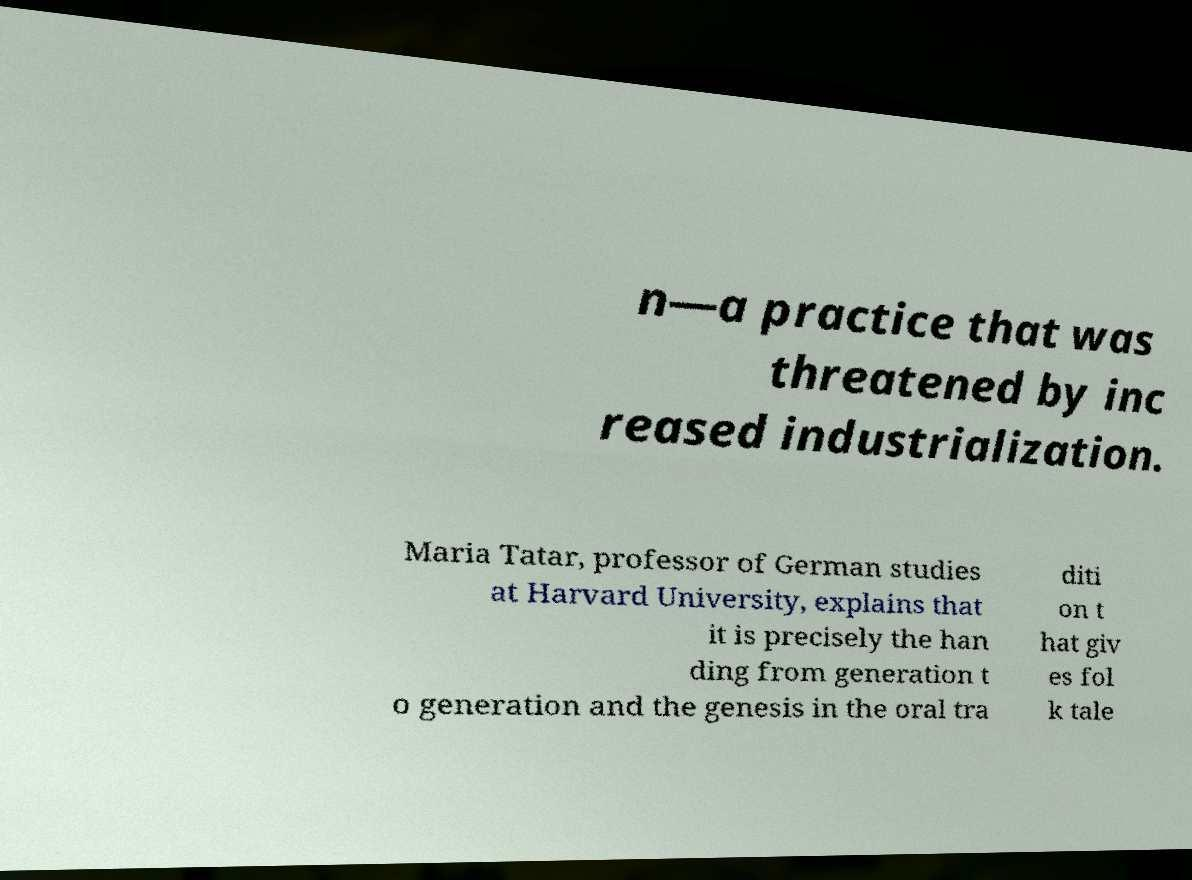Could you assist in decoding the text presented in this image and type it out clearly? n—a practice that was threatened by inc reased industrialization. Maria Tatar, professor of German studies at Harvard University, explains that it is precisely the han ding from generation t o generation and the genesis in the oral tra diti on t hat giv es fol k tale 